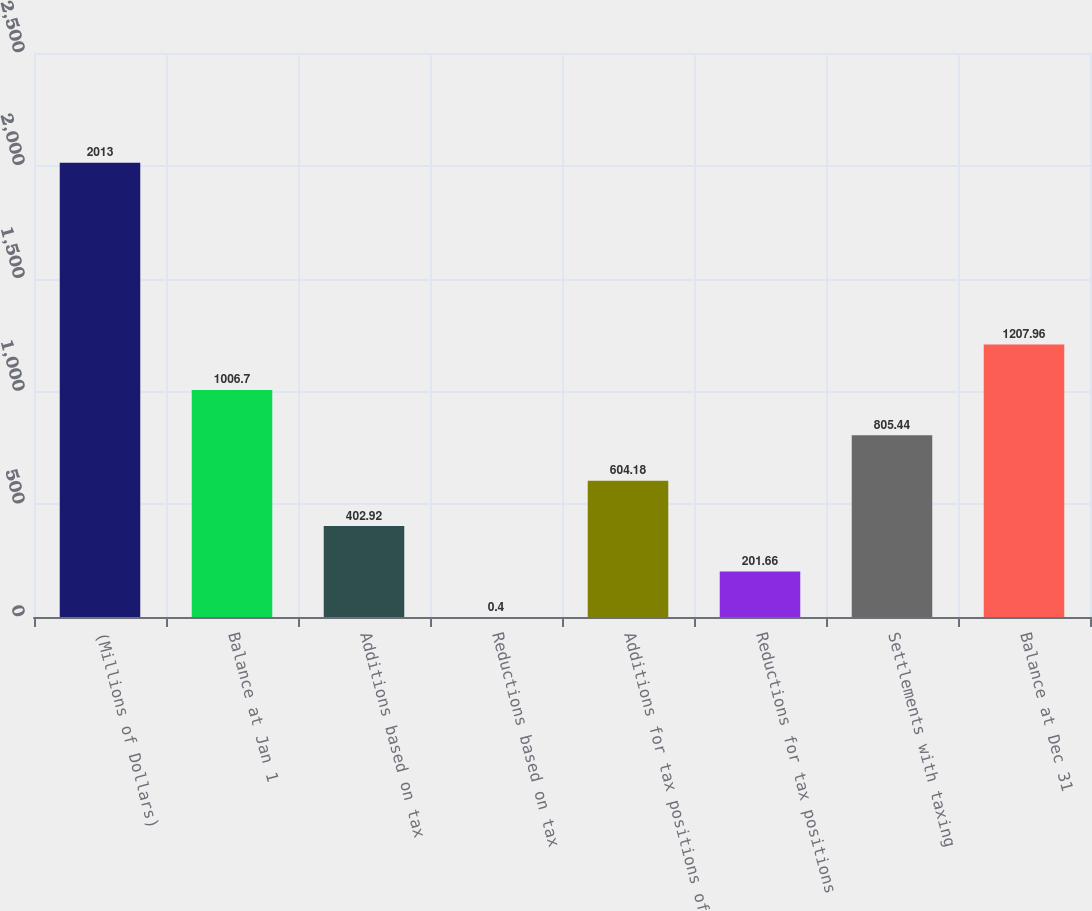Convert chart to OTSL. <chart><loc_0><loc_0><loc_500><loc_500><bar_chart><fcel>(Millions of Dollars)<fcel>Balance at Jan 1<fcel>Additions based on tax<fcel>Reductions based on tax<fcel>Additions for tax positions of<fcel>Reductions for tax positions<fcel>Settlements with taxing<fcel>Balance at Dec 31<nl><fcel>2013<fcel>1006.7<fcel>402.92<fcel>0.4<fcel>604.18<fcel>201.66<fcel>805.44<fcel>1207.96<nl></chart> 